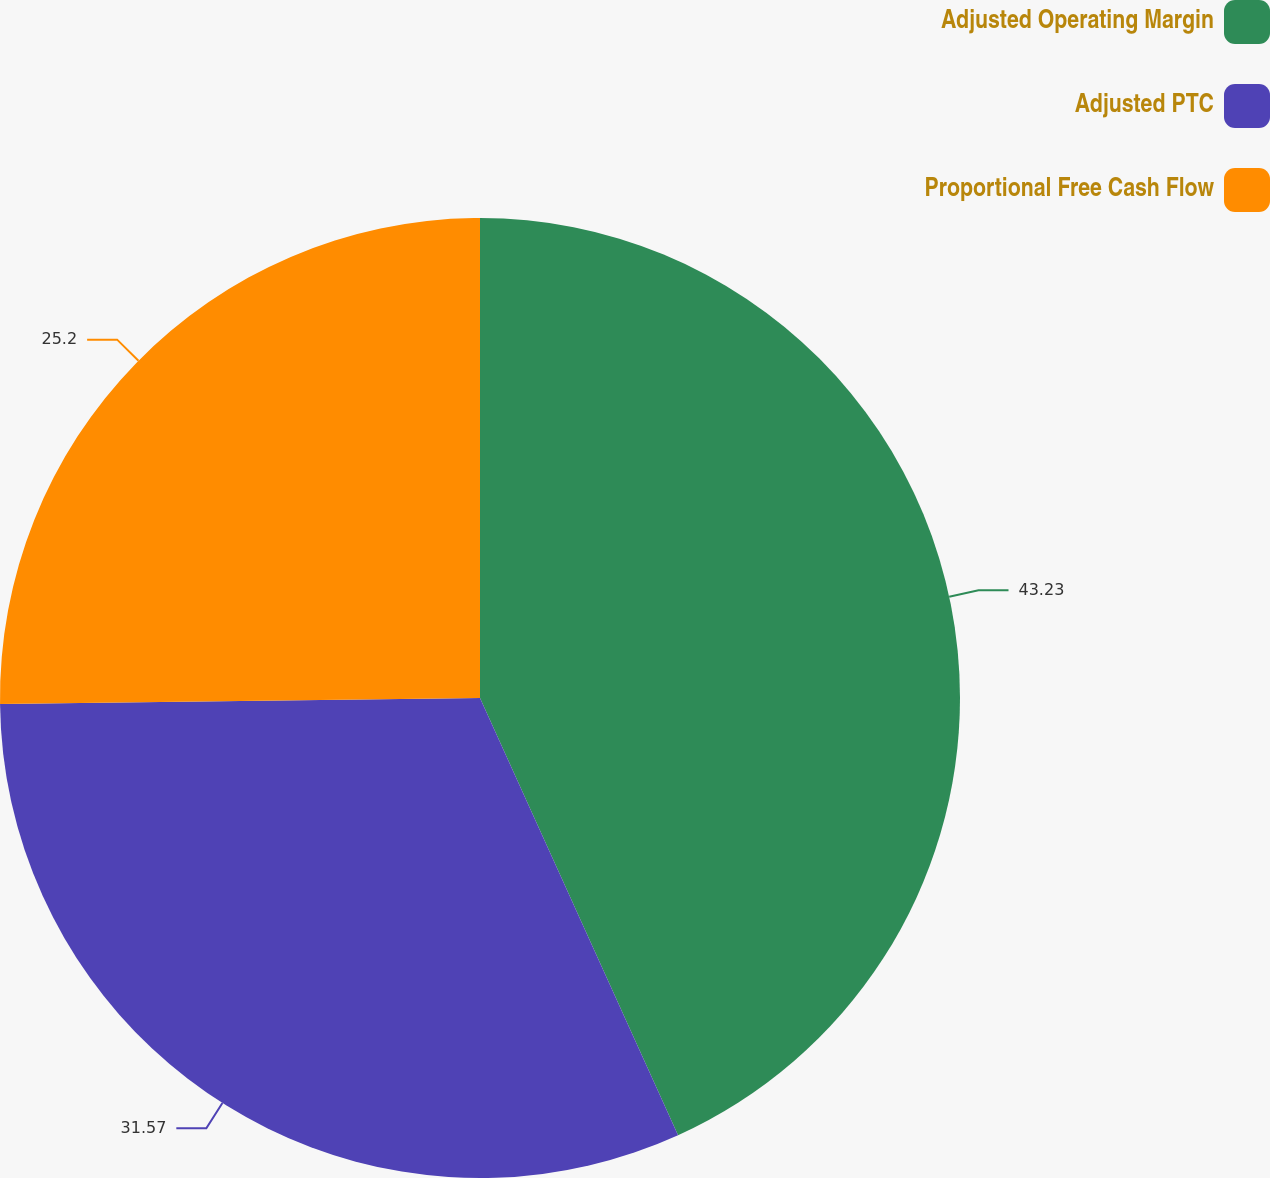<chart> <loc_0><loc_0><loc_500><loc_500><pie_chart><fcel>Adjusted Operating Margin<fcel>Adjusted PTC<fcel>Proportional Free Cash Flow<nl><fcel>43.23%<fcel>31.57%<fcel>25.2%<nl></chart> 